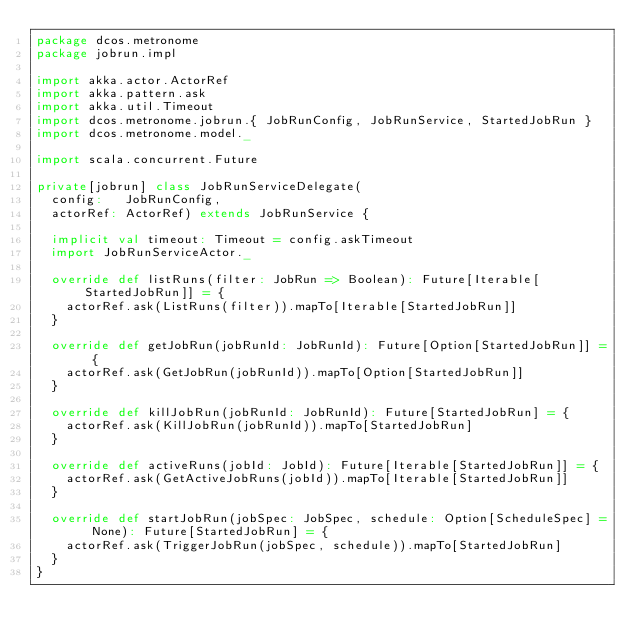Convert code to text. <code><loc_0><loc_0><loc_500><loc_500><_Scala_>package dcos.metronome
package jobrun.impl

import akka.actor.ActorRef
import akka.pattern.ask
import akka.util.Timeout
import dcos.metronome.jobrun.{ JobRunConfig, JobRunService, StartedJobRun }
import dcos.metronome.model._

import scala.concurrent.Future

private[jobrun] class JobRunServiceDelegate(
  config:   JobRunConfig,
  actorRef: ActorRef) extends JobRunService {

  implicit val timeout: Timeout = config.askTimeout
  import JobRunServiceActor._

  override def listRuns(filter: JobRun => Boolean): Future[Iterable[StartedJobRun]] = {
    actorRef.ask(ListRuns(filter)).mapTo[Iterable[StartedJobRun]]
  }

  override def getJobRun(jobRunId: JobRunId): Future[Option[StartedJobRun]] = {
    actorRef.ask(GetJobRun(jobRunId)).mapTo[Option[StartedJobRun]]
  }

  override def killJobRun(jobRunId: JobRunId): Future[StartedJobRun] = {
    actorRef.ask(KillJobRun(jobRunId)).mapTo[StartedJobRun]
  }

  override def activeRuns(jobId: JobId): Future[Iterable[StartedJobRun]] = {
    actorRef.ask(GetActiveJobRuns(jobId)).mapTo[Iterable[StartedJobRun]]
  }

  override def startJobRun(jobSpec: JobSpec, schedule: Option[ScheduleSpec] = None): Future[StartedJobRun] = {
    actorRef.ask(TriggerJobRun(jobSpec, schedule)).mapTo[StartedJobRun]
  }
}
</code> 